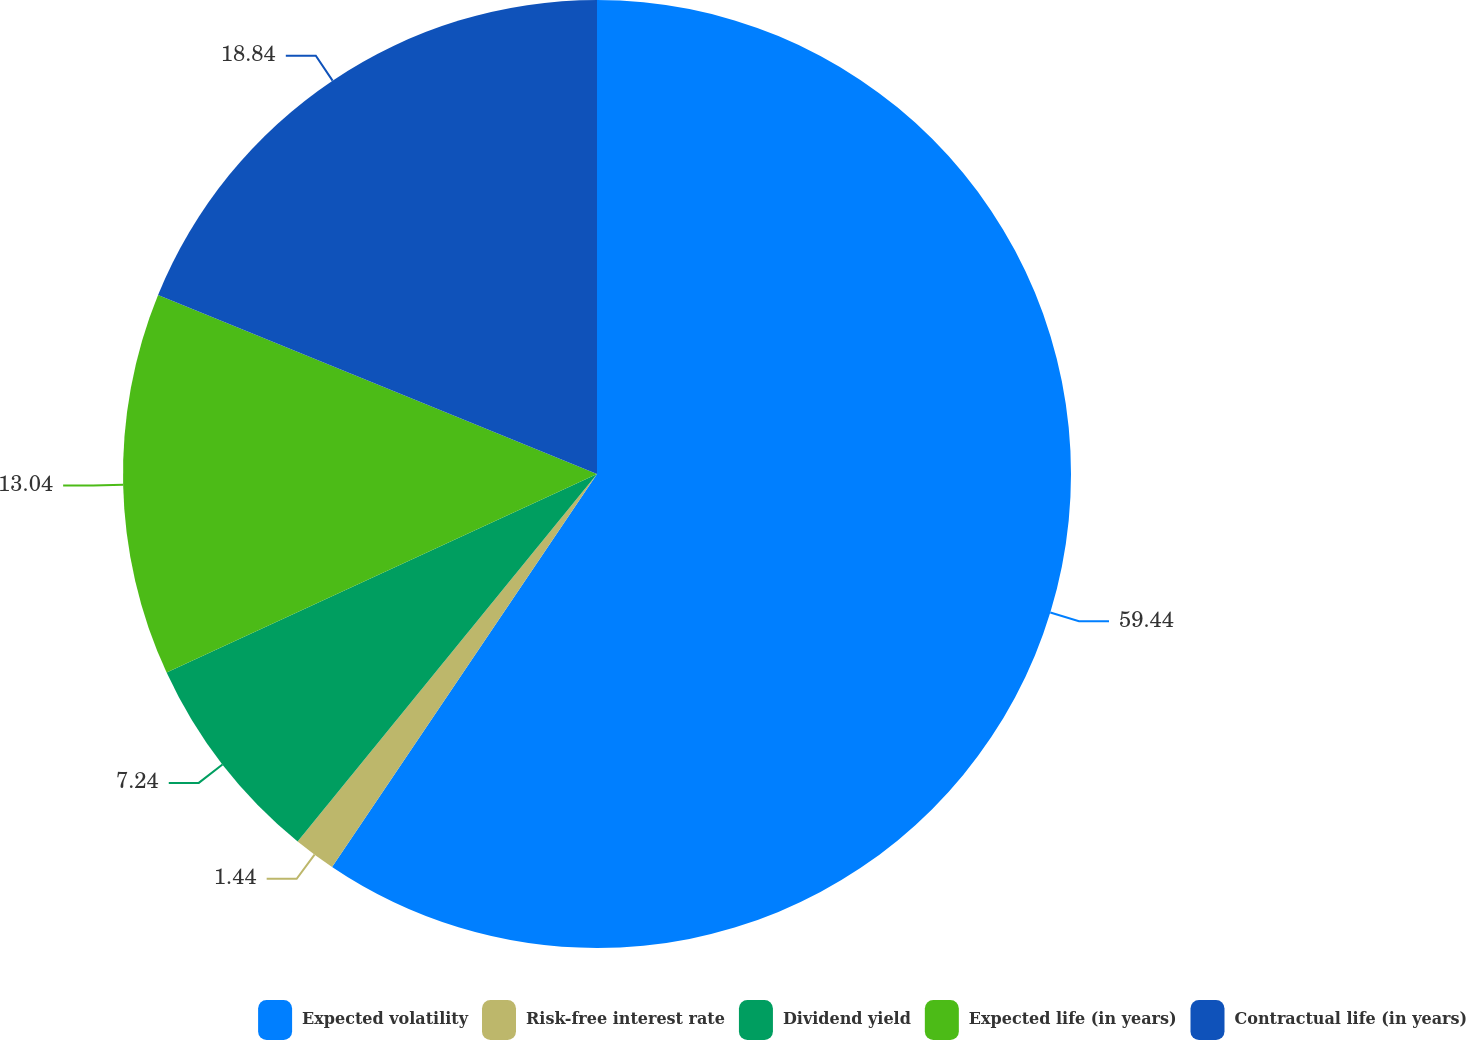Convert chart. <chart><loc_0><loc_0><loc_500><loc_500><pie_chart><fcel>Expected volatility<fcel>Risk-free interest rate<fcel>Dividend yield<fcel>Expected life (in years)<fcel>Contractual life (in years)<nl><fcel>59.44%<fcel>1.44%<fcel>7.24%<fcel>13.04%<fcel>18.84%<nl></chart> 